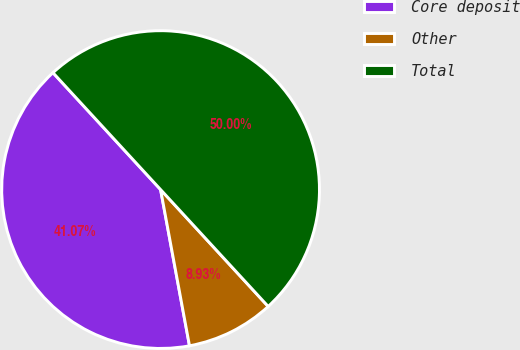Convert chart. <chart><loc_0><loc_0><loc_500><loc_500><pie_chart><fcel>Core deposit<fcel>Other<fcel>Total<nl><fcel>41.07%<fcel>8.93%<fcel>50.0%<nl></chart> 